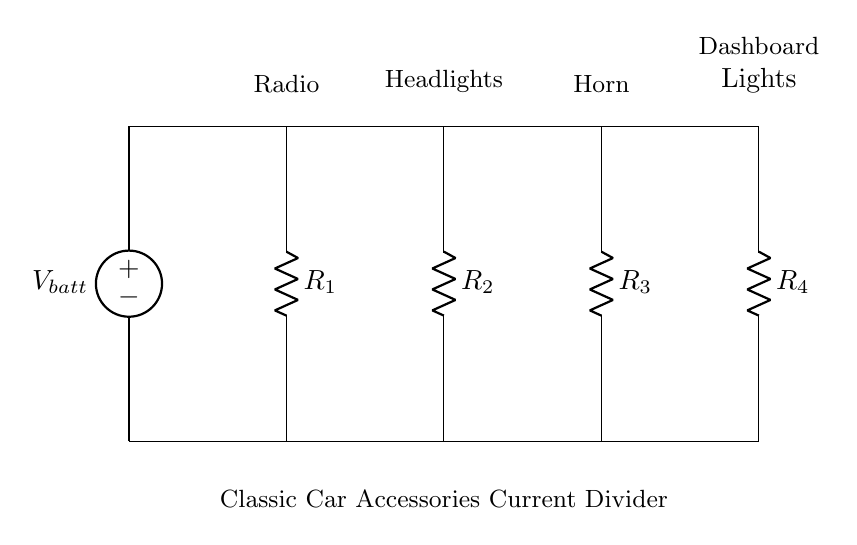What are the components used in the circuit? The circuit includes a voltage source and four resistors. Each resistor is labeled with the corresponding accessory it powers.
Answer: Voltage source, four resistors What is the purpose of this circuit? The circuit functions as a current divider to distribute power to multiple classic car accessories, ensuring each accessory receives an appropriate share of the current from the battery.
Answer: Distribute power What is the total number of accessories connected to the battery? There are four accessories connected to the battery: radio, headlights, horn, and dashboard lights. The circuit design allows the current to be divided among these accessories.
Answer: Four Which accessory is connected to the first resistor? The first resistor is labeled for the radio, indicating that it powers this specific accessory in the circuit.
Answer: Radio If the resistances are equal, how does the current divide? Since all resistances are equal, the current will divide equally among the four branches, meaning each accessory will receive one-quarter of the total current.
Answer: Equally How does increasing resistance affect the current for that branch? Increasing the resistance of a branch decreases the current flowing through it according to Ohm's law, which states that current is inversely proportional to resistance when voltage is constant.
Answer: Decrease What is the relationship between current and resistance for the accessories? The current flowing through each accessory is inversely proportional to its resistance as per Ohm's law; higher resistance results in lower current for that accessory if the total voltage is kept constant.
Answer: Inverse relationship 